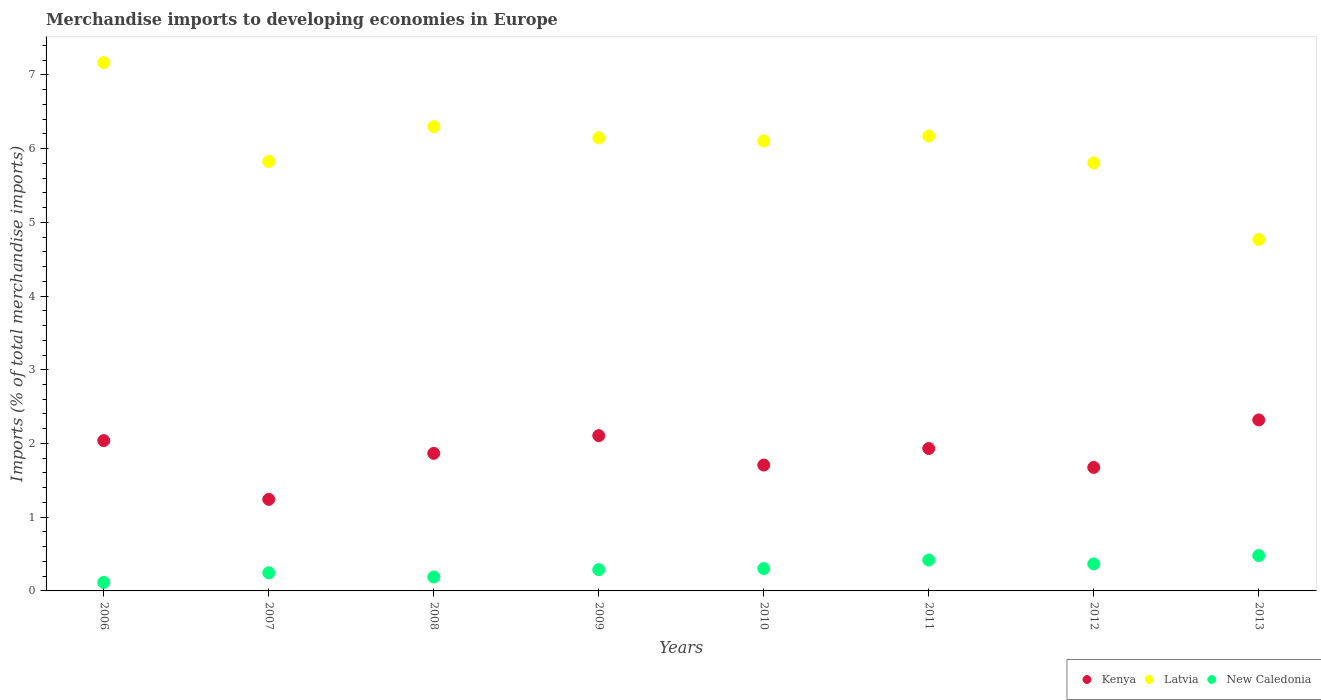What is the percentage total merchandise imports in New Caledonia in 2010?
Provide a short and direct response. 0.3. Across all years, what is the maximum percentage total merchandise imports in Latvia?
Give a very brief answer. 7.17. Across all years, what is the minimum percentage total merchandise imports in New Caledonia?
Your answer should be compact. 0.12. In which year was the percentage total merchandise imports in Kenya maximum?
Provide a succinct answer. 2013. In which year was the percentage total merchandise imports in Kenya minimum?
Provide a succinct answer. 2007. What is the total percentage total merchandise imports in Latvia in the graph?
Provide a succinct answer. 48.28. What is the difference between the percentage total merchandise imports in New Caledonia in 2007 and that in 2012?
Your answer should be very brief. -0.12. What is the difference between the percentage total merchandise imports in Kenya in 2007 and the percentage total merchandise imports in Latvia in 2010?
Provide a short and direct response. -4.86. What is the average percentage total merchandise imports in Kenya per year?
Make the answer very short. 1.86. In the year 2013, what is the difference between the percentage total merchandise imports in Latvia and percentage total merchandise imports in New Caledonia?
Offer a terse response. 4.29. In how many years, is the percentage total merchandise imports in Kenya greater than 6.8 %?
Keep it short and to the point. 0. What is the ratio of the percentage total merchandise imports in New Caledonia in 2009 to that in 2010?
Your response must be concise. 0.95. What is the difference between the highest and the second highest percentage total merchandise imports in Kenya?
Your answer should be compact. 0.21. What is the difference between the highest and the lowest percentage total merchandise imports in Kenya?
Offer a very short reply. 1.08. In how many years, is the percentage total merchandise imports in Kenya greater than the average percentage total merchandise imports in Kenya taken over all years?
Your answer should be compact. 5. Is the sum of the percentage total merchandise imports in New Caledonia in 2009 and 2011 greater than the maximum percentage total merchandise imports in Latvia across all years?
Make the answer very short. No. Is it the case that in every year, the sum of the percentage total merchandise imports in New Caledonia and percentage total merchandise imports in Latvia  is greater than the percentage total merchandise imports in Kenya?
Your answer should be very brief. Yes. Does the percentage total merchandise imports in Kenya monotonically increase over the years?
Offer a terse response. No. Is the percentage total merchandise imports in New Caledonia strictly less than the percentage total merchandise imports in Kenya over the years?
Give a very brief answer. Yes. Does the graph contain any zero values?
Your answer should be very brief. No. Does the graph contain grids?
Provide a short and direct response. No. Where does the legend appear in the graph?
Offer a terse response. Bottom right. What is the title of the graph?
Keep it short and to the point. Merchandise imports to developing economies in Europe. Does "Mali" appear as one of the legend labels in the graph?
Your response must be concise. No. What is the label or title of the Y-axis?
Give a very brief answer. Imports (% of total merchandise imports). What is the Imports (% of total merchandise imports) in Kenya in 2006?
Ensure brevity in your answer.  2.04. What is the Imports (% of total merchandise imports) of Latvia in 2006?
Your answer should be compact. 7.17. What is the Imports (% of total merchandise imports) in New Caledonia in 2006?
Your answer should be compact. 0.12. What is the Imports (% of total merchandise imports) in Kenya in 2007?
Provide a short and direct response. 1.24. What is the Imports (% of total merchandise imports) of Latvia in 2007?
Provide a succinct answer. 5.83. What is the Imports (% of total merchandise imports) of New Caledonia in 2007?
Your response must be concise. 0.25. What is the Imports (% of total merchandise imports) of Kenya in 2008?
Ensure brevity in your answer.  1.87. What is the Imports (% of total merchandise imports) in Latvia in 2008?
Provide a short and direct response. 6.3. What is the Imports (% of total merchandise imports) in New Caledonia in 2008?
Provide a short and direct response. 0.19. What is the Imports (% of total merchandise imports) in Kenya in 2009?
Keep it short and to the point. 2.11. What is the Imports (% of total merchandise imports) of Latvia in 2009?
Make the answer very short. 6.15. What is the Imports (% of total merchandise imports) of New Caledonia in 2009?
Keep it short and to the point. 0.29. What is the Imports (% of total merchandise imports) of Kenya in 2010?
Offer a terse response. 1.71. What is the Imports (% of total merchandise imports) of Latvia in 2010?
Provide a short and direct response. 6.1. What is the Imports (% of total merchandise imports) in New Caledonia in 2010?
Give a very brief answer. 0.3. What is the Imports (% of total merchandise imports) in Kenya in 2011?
Offer a very short reply. 1.93. What is the Imports (% of total merchandise imports) in Latvia in 2011?
Keep it short and to the point. 6.17. What is the Imports (% of total merchandise imports) of New Caledonia in 2011?
Provide a succinct answer. 0.42. What is the Imports (% of total merchandise imports) in Kenya in 2012?
Provide a short and direct response. 1.68. What is the Imports (% of total merchandise imports) in Latvia in 2012?
Your answer should be very brief. 5.81. What is the Imports (% of total merchandise imports) in New Caledonia in 2012?
Ensure brevity in your answer.  0.37. What is the Imports (% of total merchandise imports) in Kenya in 2013?
Keep it short and to the point. 2.32. What is the Imports (% of total merchandise imports) of Latvia in 2013?
Keep it short and to the point. 4.77. What is the Imports (% of total merchandise imports) of New Caledonia in 2013?
Ensure brevity in your answer.  0.48. Across all years, what is the maximum Imports (% of total merchandise imports) of Kenya?
Provide a succinct answer. 2.32. Across all years, what is the maximum Imports (% of total merchandise imports) of Latvia?
Offer a very short reply. 7.17. Across all years, what is the maximum Imports (% of total merchandise imports) of New Caledonia?
Give a very brief answer. 0.48. Across all years, what is the minimum Imports (% of total merchandise imports) in Kenya?
Make the answer very short. 1.24. Across all years, what is the minimum Imports (% of total merchandise imports) of Latvia?
Provide a short and direct response. 4.77. Across all years, what is the minimum Imports (% of total merchandise imports) of New Caledonia?
Keep it short and to the point. 0.12. What is the total Imports (% of total merchandise imports) in Kenya in the graph?
Give a very brief answer. 14.89. What is the total Imports (% of total merchandise imports) in Latvia in the graph?
Your answer should be compact. 48.28. What is the total Imports (% of total merchandise imports) in New Caledonia in the graph?
Ensure brevity in your answer.  2.41. What is the difference between the Imports (% of total merchandise imports) of Kenya in 2006 and that in 2007?
Offer a very short reply. 0.8. What is the difference between the Imports (% of total merchandise imports) of Latvia in 2006 and that in 2007?
Offer a terse response. 1.34. What is the difference between the Imports (% of total merchandise imports) in New Caledonia in 2006 and that in 2007?
Your answer should be compact. -0.13. What is the difference between the Imports (% of total merchandise imports) in Kenya in 2006 and that in 2008?
Offer a very short reply. 0.17. What is the difference between the Imports (% of total merchandise imports) of Latvia in 2006 and that in 2008?
Your response must be concise. 0.87. What is the difference between the Imports (% of total merchandise imports) in New Caledonia in 2006 and that in 2008?
Give a very brief answer. -0.07. What is the difference between the Imports (% of total merchandise imports) of Kenya in 2006 and that in 2009?
Your answer should be compact. -0.07. What is the difference between the Imports (% of total merchandise imports) in Latvia in 2006 and that in 2009?
Keep it short and to the point. 1.02. What is the difference between the Imports (% of total merchandise imports) in New Caledonia in 2006 and that in 2009?
Give a very brief answer. -0.17. What is the difference between the Imports (% of total merchandise imports) of Kenya in 2006 and that in 2010?
Offer a terse response. 0.33. What is the difference between the Imports (% of total merchandise imports) of Latvia in 2006 and that in 2010?
Make the answer very short. 1.06. What is the difference between the Imports (% of total merchandise imports) in New Caledonia in 2006 and that in 2010?
Offer a terse response. -0.19. What is the difference between the Imports (% of total merchandise imports) in Kenya in 2006 and that in 2011?
Offer a terse response. 0.11. What is the difference between the Imports (% of total merchandise imports) of Latvia in 2006 and that in 2011?
Your response must be concise. 1. What is the difference between the Imports (% of total merchandise imports) in New Caledonia in 2006 and that in 2011?
Keep it short and to the point. -0.3. What is the difference between the Imports (% of total merchandise imports) of Kenya in 2006 and that in 2012?
Give a very brief answer. 0.36. What is the difference between the Imports (% of total merchandise imports) in Latvia in 2006 and that in 2012?
Your answer should be compact. 1.36. What is the difference between the Imports (% of total merchandise imports) of New Caledonia in 2006 and that in 2012?
Keep it short and to the point. -0.25. What is the difference between the Imports (% of total merchandise imports) in Kenya in 2006 and that in 2013?
Make the answer very short. -0.28. What is the difference between the Imports (% of total merchandise imports) of Latvia in 2006 and that in 2013?
Give a very brief answer. 2.4. What is the difference between the Imports (% of total merchandise imports) of New Caledonia in 2006 and that in 2013?
Ensure brevity in your answer.  -0.36. What is the difference between the Imports (% of total merchandise imports) of Kenya in 2007 and that in 2008?
Provide a succinct answer. -0.62. What is the difference between the Imports (% of total merchandise imports) of Latvia in 2007 and that in 2008?
Ensure brevity in your answer.  -0.47. What is the difference between the Imports (% of total merchandise imports) in New Caledonia in 2007 and that in 2008?
Your answer should be very brief. 0.06. What is the difference between the Imports (% of total merchandise imports) in Kenya in 2007 and that in 2009?
Provide a short and direct response. -0.86. What is the difference between the Imports (% of total merchandise imports) of Latvia in 2007 and that in 2009?
Keep it short and to the point. -0.32. What is the difference between the Imports (% of total merchandise imports) in New Caledonia in 2007 and that in 2009?
Offer a terse response. -0.04. What is the difference between the Imports (% of total merchandise imports) of Kenya in 2007 and that in 2010?
Your answer should be very brief. -0.47. What is the difference between the Imports (% of total merchandise imports) in Latvia in 2007 and that in 2010?
Offer a very short reply. -0.28. What is the difference between the Imports (% of total merchandise imports) of New Caledonia in 2007 and that in 2010?
Offer a very short reply. -0.06. What is the difference between the Imports (% of total merchandise imports) in Kenya in 2007 and that in 2011?
Provide a succinct answer. -0.69. What is the difference between the Imports (% of total merchandise imports) in Latvia in 2007 and that in 2011?
Make the answer very short. -0.34. What is the difference between the Imports (% of total merchandise imports) of New Caledonia in 2007 and that in 2011?
Offer a terse response. -0.17. What is the difference between the Imports (% of total merchandise imports) in Kenya in 2007 and that in 2012?
Provide a succinct answer. -0.43. What is the difference between the Imports (% of total merchandise imports) of Latvia in 2007 and that in 2012?
Your response must be concise. 0.02. What is the difference between the Imports (% of total merchandise imports) of New Caledonia in 2007 and that in 2012?
Provide a succinct answer. -0.12. What is the difference between the Imports (% of total merchandise imports) of Kenya in 2007 and that in 2013?
Your answer should be compact. -1.08. What is the difference between the Imports (% of total merchandise imports) of Latvia in 2007 and that in 2013?
Keep it short and to the point. 1.06. What is the difference between the Imports (% of total merchandise imports) in New Caledonia in 2007 and that in 2013?
Keep it short and to the point. -0.23. What is the difference between the Imports (% of total merchandise imports) in Kenya in 2008 and that in 2009?
Make the answer very short. -0.24. What is the difference between the Imports (% of total merchandise imports) of Latvia in 2008 and that in 2009?
Your answer should be compact. 0.15. What is the difference between the Imports (% of total merchandise imports) of New Caledonia in 2008 and that in 2009?
Your answer should be compact. -0.1. What is the difference between the Imports (% of total merchandise imports) of Kenya in 2008 and that in 2010?
Ensure brevity in your answer.  0.16. What is the difference between the Imports (% of total merchandise imports) in Latvia in 2008 and that in 2010?
Make the answer very short. 0.19. What is the difference between the Imports (% of total merchandise imports) in New Caledonia in 2008 and that in 2010?
Provide a succinct answer. -0.11. What is the difference between the Imports (% of total merchandise imports) of Kenya in 2008 and that in 2011?
Keep it short and to the point. -0.07. What is the difference between the Imports (% of total merchandise imports) in Latvia in 2008 and that in 2011?
Your response must be concise. 0.13. What is the difference between the Imports (% of total merchandise imports) of New Caledonia in 2008 and that in 2011?
Provide a succinct answer. -0.23. What is the difference between the Imports (% of total merchandise imports) in Kenya in 2008 and that in 2012?
Give a very brief answer. 0.19. What is the difference between the Imports (% of total merchandise imports) of Latvia in 2008 and that in 2012?
Your answer should be compact. 0.49. What is the difference between the Imports (% of total merchandise imports) in New Caledonia in 2008 and that in 2012?
Offer a terse response. -0.18. What is the difference between the Imports (% of total merchandise imports) in Kenya in 2008 and that in 2013?
Your answer should be compact. -0.45. What is the difference between the Imports (% of total merchandise imports) of Latvia in 2008 and that in 2013?
Keep it short and to the point. 1.53. What is the difference between the Imports (% of total merchandise imports) of New Caledonia in 2008 and that in 2013?
Provide a succinct answer. -0.29. What is the difference between the Imports (% of total merchandise imports) of Kenya in 2009 and that in 2010?
Offer a terse response. 0.4. What is the difference between the Imports (% of total merchandise imports) of Latvia in 2009 and that in 2010?
Provide a succinct answer. 0.04. What is the difference between the Imports (% of total merchandise imports) in New Caledonia in 2009 and that in 2010?
Your answer should be very brief. -0.01. What is the difference between the Imports (% of total merchandise imports) in Kenya in 2009 and that in 2011?
Make the answer very short. 0.17. What is the difference between the Imports (% of total merchandise imports) in Latvia in 2009 and that in 2011?
Provide a succinct answer. -0.02. What is the difference between the Imports (% of total merchandise imports) in New Caledonia in 2009 and that in 2011?
Offer a very short reply. -0.13. What is the difference between the Imports (% of total merchandise imports) of Kenya in 2009 and that in 2012?
Keep it short and to the point. 0.43. What is the difference between the Imports (% of total merchandise imports) in Latvia in 2009 and that in 2012?
Your answer should be compact. 0.34. What is the difference between the Imports (% of total merchandise imports) in New Caledonia in 2009 and that in 2012?
Provide a short and direct response. -0.08. What is the difference between the Imports (% of total merchandise imports) in Kenya in 2009 and that in 2013?
Keep it short and to the point. -0.21. What is the difference between the Imports (% of total merchandise imports) of Latvia in 2009 and that in 2013?
Give a very brief answer. 1.38. What is the difference between the Imports (% of total merchandise imports) in New Caledonia in 2009 and that in 2013?
Offer a very short reply. -0.19. What is the difference between the Imports (% of total merchandise imports) in Kenya in 2010 and that in 2011?
Provide a succinct answer. -0.22. What is the difference between the Imports (% of total merchandise imports) of Latvia in 2010 and that in 2011?
Offer a very short reply. -0.07. What is the difference between the Imports (% of total merchandise imports) of New Caledonia in 2010 and that in 2011?
Offer a very short reply. -0.12. What is the difference between the Imports (% of total merchandise imports) in Kenya in 2010 and that in 2012?
Your answer should be compact. 0.03. What is the difference between the Imports (% of total merchandise imports) in Latvia in 2010 and that in 2012?
Provide a short and direct response. 0.3. What is the difference between the Imports (% of total merchandise imports) of New Caledonia in 2010 and that in 2012?
Your answer should be compact. -0.06. What is the difference between the Imports (% of total merchandise imports) of Kenya in 2010 and that in 2013?
Your response must be concise. -0.61. What is the difference between the Imports (% of total merchandise imports) in Latvia in 2010 and that in 2013?
Keep it short and to the point. 1.34. What is the difference between the Imports (% of total merchandise imports) of New Caledonia in 2010 and that in 2013?
Offer a terse response. -0.18. What is the difference between the Imports (% of total merchandise imports) of Kenya in 2011 and that in 2012?
Provide a short and direct response. 0.26. What is the difference between the Imports (% of total merchandise imports) in Latvia in 2011 and that in 2012?
Your answer should be very brief. 0.36. What is the difference between the Imports (% of total merchandise imports) in New Caledonia in 2011 and that in 2012?
Ensure brevity in your answer.  0.05. What is the difference between the Imports (% of total merchandise imports) in Kenya in 2011 and that in 2013?
Your answer should be compact. -0.39. What is the difference between the Imports (% of total merchandise imports) of Latvia in 2011 and that in 2013?
Ensure brevity in your answer.  1.4. What is the difference between the Imports (% of total merchandise imports) of New Caledonia in 2011 and that in 2013?
Offer a very short reply. -0.06. What is the difference between the Imports (% of total merchandise imports) in Kenya in 2012 and that in 2013?
Keep it short and to the point. -0.64. What is the difference between the Imports (% of total merchandise imports) of Latvia in 2012 and that in 2013?
Make the answer very short. 1.04. What is the difference between the Imports (% of total merchandise imports) of New Caledonia in 2012 and that in 2013?
Your response must be concise. -0.11. What is the difference between the Imports (% of total merchandise imports) in Kenya in 2006 and the Imports (% of total merchandise imports) in Latvia in 2007?
Your answer should be very brief. -3.79. What is the difference between the Imports (% of total merchandise imports) of Kenya in 2006 and the Imports (% of total merchandise imports) of New Caledonia in 2007?
Give a very brief answer. 1.79. What is the difference between the Imports (% of total merchandise imports) in Latvia in 2006 and the Imports (% of total merchandise imports) in New Caledonia in 2007?
Your answer should be very brief. 6.92. What is the difference between the Imports (% of total merchandise imports) of Kenya in 2006 and the Imports (% of total merchandise imports) of Latvia in 2008?
Your response must be concise. -4.26. What is the difference between the Imports (% of total merchandise imports) of Kenya in 2006 and the Imports (% of total merchandise imports) of New Caledonia in 2008?
Provide a succinct answer. 1.85. What is the difference between the Imports (% of total merchandise imports) in Latvia in 2006 and the Imports (% of total merchandise imports) in New Caledonia in 2008?
Keep it short and to the point. 6.98. What is the difference between the Imports (% of total merchandise imports) in Kenya in 2006 and the Imports (% of total merchandise imports) in Latvia in 2009?
Offer a terse response. -4.11. What is the difference between the Imports (% of total merchandise imports) of Kenya in 2006 and the Imports (% of total merchandise imports) of New Caledonia in 2009?
Give a very brief answer. 1.75. What is the difference between the Imports (% of total merchandise imports) of Latvia in 2006 and the Imports (% of total merchandise imports) of New Caledonia in 2009?
Give a very brief answer. 6.88. What is the difference between the Imports (% of total merchandise imports) of Kenya in 2006 and the Imports (% of total merchandise imports) of Latvia in 2010?
Your response must be concise. -4.06. What is the difference between the Imports (% of total merchandise imports) in Kenya in 2006 and the Imports (% of total merchandise imports) in New Caledonia in 2010?
Offer a very short reply. 1.74. What is the difference between the Imports (% of total merchandise imports) of Latvia in 2006 and the Imports (% of total merchandise imports) of New Caledonia in 2010?
Give a very brief answer. 6.86. What is the difference between the Imports (% of total merchandise imports) of Kenya in 2006 and the Imports (% of total merchandise imports) of Latvia in 2011?
Your response must be concise. -4.13. What is the difference between the Imports (% of total merchandise imports) in Kenya in 2006 and the Imports (% of total merchandise imports) in New Caledonia in 2011?
Make the answer very short. 1.62. What is the difference between the Imports (% of total merchandise imports) in Latvia in 2006 and the Imports (% of total merchandise imports) in New Caledonia in 2011?
Your answer should be compact. 6.75. What is the difference between the Imports (% of total merchandise imports) in Kenya in 2006 and the Imports (% of total merchandise imports) in Latvia in 2012?
Keep it short and to the point. -3.77. What is the difference between the Imports (% of total merchandise imports) of Kenya in 2006 and the Imports (% of total merchandise imports) of New Caledonia in 2012?
Make the answer very short. 1.67. What is the difference between the Imports (% of total merchandise imports) in Latvia in 2006 and the Imports (% of total merchandise imports) in New Caledonia in 2012?
Keep it short and to the point. 6.8. What is the difference between the Imports (% of total merchandise imports) in Kenya in 2006 and the Imports (% of total merchandise imports) in Latvia in 2013?
Your answer should be very brief. -2.73. What is the difference between the Imports (% of total merchandise imports) in Kenya in 2006 and the Imports (% of total merchandise imports) in New Caledonia in 2013?
Offer a very short reply. 1.56. What is the difference between the Imports (% of total merchandise imports) in Latvia in 2006 and the Imports (% of total merchandise imports) in New Caledonia in 2013?
Offer a very short reply. 6.69. What is the difference between the Imports (% of total merchandise imports) in Kenya in 2007 and the Imports (% of total merchandise imports) in Latvia in 2008?
Offer a terse response. -5.06. What is the difference between the Imports (% of total merchandise imports) in Kenya in 2007 and the Imports (% of total merchandise imports) in New Caledonia in 2008?
Provide a short and direct response. 1.05. What is the difference between the Imports (% of total merchandise imports) in Latvia in 2007 and the Imports (% of total merchandise imports) in New Caledonia in 2008?
Keep it short and to the point. 5.64. What is the difference between the Imports (% of total merchandise imports) of Kenya in 2007 and the Imports (% of total merchandise imports) of Latvia in 2009?
Keep it short and to the point. -4.9. What is the difference between the Imports (% of total merchandise imports) in Kenya in 2007 and the Imports (% of total merchandise imports) in New Caledonia in 2009?
Keep it short and to the point. 0.95. What is the difference between the Imports (% of total merchandise imports) in Latvia in 2007 and the Imports (% of total merchandise imports) in New Caledonia in 2009?
Offer a very short reply. 5.54. What is the difference between the Imports (% of total merchandise imports) in Kenya in 2007 and the Imports (% of total merchandise imports) in Latvia in 2010?
Offer a terse response. -4.86. What is the difference between the Imports (% of total merchandise imports) of Kenya in 2007 and the Imports (% of total merchandise imports) of New Caledonia in 2010?
Provide a succinct answer. 0.94. What is the difference between the Imports (% of total merchandise imports) in Latvia in 2007 and the Imports (% of total merchandise imports) in New Caledonia in 2010?
Keep it short and to the point. 5.52. What is the difference between the Imports (% of total merchandise imports) in Kenya in 2007 and the Imports (% of total merchandise imports) in Latvia in 2011?
Offer a terse response. -4.93. What is the difference between the Imports (% of total merchandise imports) of Kenya in 2007 and the Imports (% of total merchandise imports) of New Caledonia in 2011?
Your response must be concise. 0.82. What is the difference between the Imports (% of total merchandise imports) of Latvia in 2007 and the Imports (% of total merchandise imports) of New Caledonia in 2011?
Make the answer very short. 5.41. What is the difference between the Imports (% of total merchandise imports) of Kenya in 2007 and the Imports (% of total merchandise imports) of Latvia in 2012?
Make the answer very short. -4.56. What is the difference between the Imports (% of total merchandise imports) in Kenya in 2007 and the Imports (% of total merchandise imports) in New Caledonia in 2012?
Your answer should be very brief. 0.88. What is the difference between the Imports (% of total merchandise imports) of Latvia in 2007 and the Imports (% of total merchandise imports) of New Caledonia in 2012?
Offer a terse response. 5.46. What is the difference between the Imports (% of total merchandise imports) in Kenya in 2007 and the Imports (% of total merchandise imports) in Latvia in 2013?
Give a very brief answer. -3.52. What is the difference between the Imports (% of total merchandise imports) of Kenya in 2007 and the Imports (% of total merchandise imports) of New Caledonia in 2013?
Provide a short and direct response. 0.76. What is the difference between the Imports (% of total merchandise imports) of Latvia in 2007 and the Imports (% of total merchandise imports) of New Caledonia in 2013?
Offer a very short reply. 5.35. What is the difference between the Imports (% of total merchandise imports) in Kenya in 2008 and the Imports (% of total merchandise imports) in Latvia in 2009?
Provide a short and direct response. -4.28. What is the difference between the Imports (% of total merchandise imports) in Kenya in 2008 and the Imports (% of total merchandise imports) in New Caledonia in 2009?
Provide a short and direct response. 1.58. What is the difference between the Imports (% of total merchandise imports) of Latvia in 2008 and the Imports (% of total merchandise imports) of New Caledonia in 2009?
Provide a succinct answer. 6.01. What is the difference between the Imports (% of total merchandise imports) of Kenya in 2008 and the Imports (% of total merchandise imports) of Latvia in 2010?
Keep it short and to the point. -4.24. What is the difference between the Imports (% of total merchandise imports) of Kenya in 2008 and the Imports (% of total merchandise imports) of New Caledonia in 2010?
Provide a succinct answer. 1.56. What is the difference between the Imports (% of total merchandise imports) in Latvia in 2008 and the Imports (% of total merchandise imports) in New Caledonia in 2010?
Your answer should be very brief. 6. What is the difference between the Imports (% of total merchandise imports) in Kenya in 2008 and the Imports (% of total merchandise imports) in Latvia in 2011?
Your answer should be very brief. -4.3. What is the difference between the Imports (% of total merchandise imports) of Kenya in 2008 and the Imports (% of total merchandise imports) of New Caledonia in 2011?
Offer a terse response. 1.45. What is the difference between the Imports (% of total merchandise imports) in Latvia in 2008 and the Imports (% of total merchandise imports) in New Caledonia in 2011?
Offer a very short reply. 5.88. What is the difference between the Imports (% of total merchandise imports) in Kenya in 2008 and the Imports (% of total merchandise imports) in Latvia in 2012?
Your response must be concise. -3.94. What is the difference between the Imports (% of total merchandise imports) of Kenya in 2008 and the Imports (% of total merchandise imports) of New Caledonia in 2012?
Your answer should be compact. 1.5. What is the difference between the Imports (% of total merchandise imports) of Latvia in 2008 and the Imports (% of total merchandise imports) of New Caledonia in 2012?
Give a very brief answer. 5.93. What is the difference between the Imports (% of total merchandise imports) of Kenya in 2008 and the Imports (% of total merchandise imports) of Latvia in 2013?
Your response must be concise. -2.9. What is the difference between the Imports (% of total merchandise imports) in Kenya in 2008 and the Imports (% of total merchandise imports) in New Caledonia in 2013?
Give a very brief answer. 1.39. What is the difference between the Imports (% of total merchandise imports) of Latvia in 2008 and the Imports (% of total merchandise imports) of New Caledonia in 2013?
Ensure brevity in your answer.  5.82. What is the difference between the Imports (% of total merchandise imports) in Kenya in 2009 and the Imports (% of total merchandise imports) in Latvia in 2010?
Your answer should be very brief. -4. What is the difference between the Imports (% of total merchandise imports) in Kenya in 2009 and the Imports (% of total merchandise imports) in New Caledonia in 2010?
Provide a short and direct response. 1.8. What is the difference between the Imports (% of total merchandise imports) of Latvia in 2009 and the Imports (% of total merchandise imports) of New Caledonia in 2010?
Provide a succinct answer. 5.84. What is the difference between the Imports (% of total merchandise imports) in Kenya in 2009 and the Imports (% of total merchandise imports) in Latvia in 2011?
Provide a short and direct response. -4.06. What is the difference between the Imports (% of total merchandise imports) in Kenya in 2009 and the Imports (% of total merchandise imports) in New Caledonia in 2011?
Provide a succinct answer. 1.69. What is the difference between the Imports (% of total merchandise imports) in Latvia in 2009 and the Imports (% of total merchandise imports) in New Caledonia in 2011?
Make the answer very short. 5.73. What is the difference between the Imports (% of total merchandise imports) of Kenya in 2009 and the Imports (% of total merchandise imports) of Latvia in 2012?
Keep it short and to the point. -3.7. What is the difference between the Imports (% of total merchandise imports) of Kenya in 2009 and the Imports (% of total merchandise imports) of New Caledonia in 2012?
Your answer should be compact. 1.74. What is the difference between the Imports (% of total merchandise imports) of Latvia in 2009 and the Imports (% of total merchandise imports) of New Caledonia in 2012?
Offer a very short reply. 5.78. What is the difference between the Imports (% of total merchandise imports) of Kenya in 2009 and the Imports (% of total merchandise imports) of Latvia in 2013?
Provide a short and direct response. -2.66. What is the difference between the Imports (% of total merchandise imports) in Kenya in 2009 and the Imports (% of total merchandise imports) in New Caledonia in 2013?
Provide a succinct answer. 1.63. What is the difference between the Imports (% of total merchandise imports) in Latvia in 2009 and the Imports (% of total merchandise imports) in New Caledonia in 2013?
Give a very brief answer. 5.67. What is the difference between the Imports (% of total merchandise imports) in Kenya in 2010 and the Imports (% of total merchandise imports) in Latvia in 2011?
Your answer should be compact. -4.46. What is the difference between the Imports (% of total merchandise imports) in Kenya in 2010 and the Imports (% of total merchandise imports) in New Caledonia in 2011?
Make the answer very short. 1.29. What is the difference between the Imports (% of total merchandise imports) in Latvia in 2010 and the Imports (% of total merchandise imports) in New Caledonia in 2011?
Your response must be concise. 5.68. What is the difference between the Imports (% of total merchandise imports) in Kenya in 2010 and the Imports (% of total merchandise imports) in Latvia in 2012?
Ensure brevity in your answer.  -4.1. What is the difference between the Imports (% of total merchandise imports) in Kenya in 2010 and the Imports (% of total merchandise imports) in New Caledonia in 2012?
Ensure brevity in your answer.  1.34. What is the difference between the Imports (% of total merchandise imports) in Latvia in 2010 and the Imports (% of total merchandise imports) in New Caledonia in 2012?
Provide a short and direct response. 5.74. What is the difference between the Imports (% of total merchandise imports) in Kenya in 2010 and the Imports (% of total merchandise imports) in Latvia in 2013?
Keep it short and to the point. -3.06. What is the difference between the Imports (% of total merchandise imports) in Kenya in 2010 and the Imports (% of total merchandise imports) in New Caledonia in 2013?
Your response must be concise. 1.23. What is the difference between the Imports (% of total merchandise imports) in Latvia in 2010 and the Imports (% of total merchandise imports) in New Caledonia in 2013?
Provide a succinct answer. 5.62. What is the difference between the Imports (% of total merchandise imports) of Kenya in 2011 and the Imports (% of total merchandise imports) of Latvia in 2012?
Provide a succinct answer. -3.87. What is the difference between the Imports (% of total merchandise imports) of Kenya in 2011 and the Imports (% of total merchandise imports) of New Caledonia in 2012?
Offer a terse response. 1.57. What is the difference between the Imports (% of total merchandise imports) of Latvia in 2011 and the Imports (% of total merchandise imports) of New Caledonia in 2012?
Offer a very short reply. 5.8. What is the difference between the Imports (% of total merchandise imports) in Kenya in 2011 and the Imports (% of total merchandise imports) in Latvia in 2013?
Provide a succinct answer. -2.83. What is the difference between the Imports (% of total merchandise imports) in Kenya in 2011 and the Imports (% of total merchandise imports) in New Caledonia in 2013?
Ensure brevity in your answer.  1.45. What is the difference between the Imports (% of total merchandise imports) of Latvia in 2011 and the Imports (% of total merchandise imports) of New Caledonia in 2013?
Your answer should be compact. 5.69. What is the difference between the Imports (% of total merchandise imports) of Kenya in 2012 and the Imports (% of total merchandise imports) of Latvia in 2013?
Keep it short and to the point. -3.09. What is the difference between the Imports (% of total merchandise imports) in Kenya in 2012 and the Imports (% of total merchandise imports) in New Caledonia in 2013?
Keep it short and to the point. 1.2. What is the difference between the Imports (% of total merchandise imports) of Latvia in 2012 and the Imports (% of total merchandise imports) of New Caledonia in 2013?
Offer a terse response. 5.33. What is the average Imports (% of total merchandise imports) in Kenya per year?
Provide a succinct answer. 1.86. What is the average Imports (% of total merchandise imports) in Latvia per year?
Provide a short and direct response. 6.04. What is the average Imports (% of total merchandise imports) in New Caledonia per year?
Your answer should be compact. 0.3. In the year 2006, what is the difference between the Imports (% of total merchandise imports) in Kenya and Imports (% of total merchandise imports) in Latvia?
Make the answer very short. -5.13. In the year 2006, what is the difference between the Imports (% of total merchandise imports) in Kenya and Imports (% of total merchandise imports) in New Caledonia?
Keep it short and to the point. 1.92. In the year 2006, what is the difference between the Imports (% of total merchandise imports) in Latvia and Imports (% of total merchandise imports) in New Caledonia?
Offer a very short reply. 7.05. In the year 2007, what is the difference between the Imports (% of total merchandise imports) of Kenya and Imports (% of total merchandise imports) of Latvia?
Ensure brevity in your answer.  -4.58. In the year 2007, what is the difference between the Imports (% of total merchandise imports) of Kenya and Imports (% of total merchandise imports) of New Caledonia?
Give a very brief answer. 1. In the year 2007, what is the difference between the Imports (% of total merchandise imports) of Latvia and Imports (% of total merchandise imports) of New Caledonia?
Ensure brevity in your answer.  5.58. In the year 2008, what is the difference between the Imports (% of total merchandise imports) in Kenya and Imports (% of total merchandise imports) in Latvia?
Offer a very short reply. -4.43. In the year 2008, what is the difference between the Imports (% of total merchandise imports) of Kenya and Imports (% of total merchandise imports) of New Caledonia?
Your response must be concise. 1.68. In the year 2008, what is the difference between the Imports (% of total merchandise imports) of Latvia and Imports (% of total merchandise imports) of New Caledonia?
Keep it short and to the point. 6.11. In the year 2009, what is the difference between the Imports (% of total merchandise imports) of Kenya and Imports (% of total merchandise imports) of Latvia?
Provide a short and direct response. -4.04. In the year 2009, what is the difference between the Imports (% of total merchandise imports) of Kenya and Imports (% of total merchandise imports) of New Caledonia?
Your answer should be compact. 1.82. In the year 2009, what is the difference between the Imports (% of total merchandise imports) of Latvia and Imports (% of total merchandise imports) of New Caledonia?
Provide a short and direct response. 5.86. In the year 2010, what is the difference between the Imports (% of total merchandise imports) in Kenya and Imports (% of total merchandise imports) in Latvia?
Provide a succinct answer. -4.4. In the year 2010, what is the difference between the Imports (% of total merchandise imports) in Kenya and Imports (% of total merchandise imports) in New Caledonia?
Offer a terse response. 1.4. In the year 2010, what is the difference between the Imports (% of total merchandise imports) of Latvia and Imports (% of total merchandise imports) of New Caledonia?
Offer a very short reply. 5.8. In the year 2011, what is the difference between the Imports (% of total merchandise imports) of Kenya and Imports (% of total merchandise imports) of Latvia?
Your answer should be compact. -4.24. In the year 2011, what is the difference between the Imports (% of total merchandise imports) in Kenya and Imports (% of total merchandise imports) in New Caledonia?
Offer a very short reply. 1.51. In the year 2011, what is the difference between the Imports (% of total merchandise imports) of Latvia and Imports (% of total merchandise imports) of New Caledonia?
Offer a terse response. 5.75. In the year 2012, what is the difference between the Imports (% of total merchandise imports) in Kenya and Imports (% of total merchandise imports) in Latvia?
Make the answer very short. -4.13. In the year 2012, what is the difference between the Imports (% of total merchandise imports) in Kenya and Imports (% of total merchandise imports) in New Caledonia?
Keep it short and to the point. 1.31. In the year 2012, what is the difference between the Imports (% of total merchandise imports) in Latvia and Imports (% of total merchandise imports) in New Caledonia?
Your answer should be very brief. 5.44. In the year 2013, what is the difference between the Imports (% of total merchandise imports) of Kenya and Imports (% of total merchandise imports) of Latvia?
Ensure brevity in your answer.  -2.45. In the year 2013, what is the difference between the Imports (% of total merchandise imports) of Kenya and Imports (% of total merchandise imports) of New Caledonia?
Your answer should be very brief. 1.84. In the year 2013, what is the difference between the Imports (% of total merchandise imports) of Latvia and Imports (% of total merchandise imports) of New Caledonia?
Offer a terse response. 4.29. What is the ratio of the Imports (% of total merchandise imports) of Kenya in 2006 to that in 2007?
Offer a very short reply. 1.64. What is the ratio of the Imports (% of total merchandise imports) of Latvia in 2006 to that in 2007?
Make the answer very short. 1.23. What is the ratio of the Imports (% of total merchandise imports) of New Caledonia in 2006 to that in 2007?
Your answer should be very brief. 0.47. What is the ratio of the Imports (% of total merchandise imports) of Kenya in 2006 to that in 2008?
Offer a terse response. 1.09. What is the ratio of the Imports (% of total merchandise imports) in Latvia in 2006 to that in 2008?
Keep it short and to the point. 1.14. What is the ratio of the Imports (% of total merchandise imports) in New Caledonia in 2006 to that in 2008?
Offer a very short reply. 0.61. What is the ratio of the Imports (% of total merchandise imports) in Kenya in 2006 to that in 2009?
Make the answer very short. 0.97. What is the ratio of the Imports (% of total merchandise imports) in Latvia in 2006 to that in 2009?
Keep it short and to the point. 1.17. What is the ratio of the Imports (% of total merchandise imports) in New Caledonia in 2006 to that in 2009?
Give a very brief answer. 0.4. What is the ratio of the Imports (% of total merchandise imports) of Kenya in 2006 to that in 2010?
Your response must be concise. 1.19. What is the ratio of the Imports (% of total merchandise imports) in Latvia in 2006 to that in 2010?
Make the answer very short. 1.17. What is the ratio of the Imports (% of total merchandise imports) of New Caledonia in 2006 to that in 2010?
Ensure brevity in your answer.  0.38. What is the ratio of the Imports (% of total merchandise imports) of Kenya in 2006 to that in 2011?
Your response must be concise. 1.06. What is the ratio of the Imports (% of total merchandise imports) in Latvia in 2006 to that in 2011?
Your answer should be very brief. 1.16. What is the ratio of the Imports (% of total merchandise imports) of New Caledonia in 2006 to that in 2011?
Keep it short and to the point. 0.28. What is the ratio of the Imports (% of total merchandise imports) of Kenya in 2006 to that in 2012?
Your answer should be compact. 1.22. What is the ratio of the Imports (% of total merchandise imports) of Latvia in 2006 to that in 2012?
Provide a short and direct response. 1.23. What is the ratio of the Imports (% of total merchandise imports) of New Caledonia in 2006 to that in 2012?
Keep it short and to the point. 0.32. What is the ratio of the Imports (% of total merchandise imports) of Kenya in 2006 to that in 2013?
Your answer should be compact. 0.88. What is the ratio of the Imports (% of total merchandise imports) in Latvia in 2006 to that in 2013?
Keep it short and to the point. 1.5. What is the ratio of the Imports (% of total merchandise imports) of New Caledonia in 2006 to that in 2013?
Offer a terse response. 0.24. What is the ratio of the Imports (% of total merchandise imports) in Kenya in 2007 to that in 2008?
Your answer should be very brief. 0.67. What is the ratio of the Imports (% of total merchandise imports) in Latvia in 2007 to that in 2008?
Provide a short and direct response. 0.93. What is the ratio of the Imports (% of total merchandise imports) of New Caledonia in 2007 to that in 2008?
Offer a very short reply. 1.3. What is the ratio of the Imports (% of total merchandise imports) of Kenya in 2007 to that in 2009?
Ensure brevity in your answer.  0.59. What is the ratio of the Imports (% of total merchandise imports) of Latvia in 2007 to that in 2009?
Keep it short and to the point. 0.95. What is the ratio of the Imports (% of total merchandise imports) in New Caledonia in 2007 to that in 2009?
Keep it short and to the point. 0.85. What is the ratio of the Imports (% of total merchandise imports) of Kenya in 2007 to that in 2010?
Give a very brief answer. 0.73. What is the ratio of the Imports (% of total merchandise imports) in Latvia in 2007 to that in 2010?
Your answer should be very brief. 0.95. What is the ratio of the Imports (% of total merchandise imports) in New Caledonia in 2007 to that in 2010?
Offer a terse response. 0.81. What is the ratio of the Imports (% of total merchandise imports) in Kenya in 2007 to that in 2011?
Keep it short and to the point. 0.64. What is the ratio of the Imports (% of total merchandise imports) in Latvia in 2007 to that in 2011?
Keep it short and to the point. 0.94. What is the ratio of the Imports (% of total merchandise imports) in New Caledonia in 2007 to that in 2011?
Make the answer very short. 0.59. What is the ratio of the Imports (% of total merchandise imports) of Kenya in 2007 to that in 2012?
Offer a very short reply. 0.74. What is the ratio of the Imports (% of total merchandise imports) in New Caledonia in 2007 to that in 2012?
Your response must be concise. 0.67. What is the ratio of the Imports (% of total merchandise imports) of Kenya in 2007 to that in 2013?
Your response must be concise. 0.54. What is the ratio of the Imports (% of total merchandise imports) of Latvia in 2007 to that in 2013?
Your answer should be compact. 1.22. What is the ratio of the Imports (% of total merchandise imports) of New Caledonia in 2007 to that in 2013?
Your answer should be very brief. 0.51. What is the ratio of the Imports (% of total merchandise imports) of Kenya in 2008 to that in 2009?
Provide a short and direct response. 0.89. What is the ratio of the Imports (% of total merchandise imports) of Latvia in 2008 to that in 2009?
Offer a terse response. 1.02. What is the ratio of the Imports (% of total merchandise imports) in New Caledonia in 2008 to that in 2009?
Make the answer very short. 0.65. What is the ratio of the Imports (% of total merchandise imports) in Kenya in 2008 to that in 2010?
Your response must be concise. 1.09. What is the ratio of the Imports (% of total merchandise imports) in Latvia in 2008 to that in 2010?
Offer a very short reply. 1.03. What is the ratio of the Imports (% of total merchandise imports) of New Caledonia in 2008 to that in 2010?
Make the answer very short. 0.62. What is the ratio of the Imports (% of total merchandise imports) of Kenya in 2008 to that in 2011?
Provide a succinct answer. 0.97. What is the ratio of the Imports (% of total merchandise imports) of Latvia in 2008 to that in 2011?
Ensure brevity in your answer.  1.02. What is the ratio of the Imports (% of total merchandise imports) in New Caledonia in 2008 to that in 2011?
Give a very brief answer. 0.45. What is the ratio of the Imports (% of total merchandise imports) of Kenya in 2008 to that in 2012?
Keep it short and to the point. 1.11. What is the ratio of the Imports (% of total merchandise imports) in Latvia in 2008 to that in 2012?
Your answer should be compact. 1.08. What is the ratio of the Imports (% of total merchandise imports) of New Caledonia in 2008 to that in 2012?
Offer a very short reply. 0.52. What is the ratio of the Imports (% of total merchandise imports) of Kenya in 2008 to that in 2013?
Offer a very short reply. 0.8. What is the ratio of the Imports (% of total merchandise imports) of Latvia in 2008 to that in 2013?
Give a very brief answer. 1.32. What is the ratio of the Imports (% of total merchandise imports) in New Caledonia in 2008 to that in 2013?
Keep it short and to the point. 0.39. What is the ratio of the Imports (% of total merchandise imports) in Kenya in 2009 to that in 2010?
Provide a succinct answer. 1.23. What is the ratio of the Imports (% of total merchandise imports) of New Caledonia in 2009 to that in 2010?
Make the answer very short. 0.95. What is the ratio of the Imports (% of total merchandise imports) in Kenya in 2009 to that in 2011?
Ensure brevity in your answer.  1.09. What is the ratio of the Imports (% of total merchandise imports) in New Caledonia in 2009 to that in 2011?
Your answer should be very brief. 0.69. What is the ratio of the Imports (% of total merchandise imports) in Kenya in 2009 to that in 2012?
Your response must be concise. 1.26. What is the ratio of the Imports (% of total merchandise imports) in Latvia in 2009 to that in 2012?
Provide a succinct answer. 1.06. What is the ratio of the Imports (% of total merchandise imports) of New Caledonia in 2009 to that in 2012?
Make the answer very short. 0.79. What is the ratio of the Imports (% of total merchandise imports) of Kenya in 2009 to that in 2013?
Give a very brief answer. 0.91. What is the ratio of the Imports (% of total merchandise imports) of Latvia in 2009 to that in 2013?
Ensure brevity in your answer.  1.29. What is the ratio of the Imports (% of total merchandise imports) in New Caledonia in 2009 to that in 2013?
Provide a short and direct response. 0.6. What is the ratio of the Imports (% of total merchandise imports) of Kenya in 2010 to that in 2011?
Provide a short and direct response. 0.88. What is the ratio of the Imports (% of total merchandise imports) in Latvia in 2010 to that in 2011?
Offer a very short reply. 0.99. What is the ratio of the Imports (% of total merchandise imports) in New Caledonia in 2010 to that in 2011?
Offer a very short reply. 0.72. What is the ratio of the Imports (% of total merchandise imports) of Kenya in 2010 to that in 2012?
Your response must be concise. 1.02. What is the ratio of the Imports (% of total merchandise imports) of Latvia in 2010 to that in 2012?
Your answer should be compact. 1.05. What is the ratio of the Imports (% of total merchandise imports) of New Caledonia in 2010 to that in 2012?
Offer a terse response. 0.83. What is the ratio of the Imports (% of total merchandise imports) in Kenya in 2010 to that in 2013?
Ensure brevity in your answer.  0.74. What is the ratio of the Imports (% of total merchandise imports) in Latvia in 2010 to that in 2013?
Your answer should be compact. 1.28. What is the ratio of the Imports (% of total merchandise imports) of New Caledonia in 2010 to that in 2013?
Ensure brevity in your answer.  0.63. What is the ratio of the Imports (% of total merchandise imports) of Kenya in 2011 to that in 2012?
Keep it short and to the point. 1.15. What is the ratio of the Imports (% of total merchandise imports) in Latvia in 2011 to that in 2012?
Offer a terse response. 1.06. What is the ratio of the Imports (% of total merchandise imports) of New Caledonia in 2011 to that in 2012?
Ensure brevity in your answer.  1.14. What is the ratio of the Imports (% of total merchandise imports) of Kenya in 2011 to that in 2013?
Offer a very short reply. 0.83. What is the ratio of the Imports (% of total merchandise imports) in Latvia in 2011 to that in 2013?
Offer a very short reply. 1.29. What is the ratio of the Imports (% of total merchandise imports) in New Caledonia in 2011 to that in 2013?
Your answer should be compact. 0.87. What is the ratio of the Imports (% of total merchandise imports) of Kenya in 2012 to that in 2013?
Ensure brevity in your answer.  0.72. What is the ratio of the Imports (% of total merchandise imports) in Latvia in 2012 to that in 2013?
Give a very brief answer. 1.22. What is the ratio of the Imports (% of total merchandise imports) in New Caledonia in 2012 to that in 2013?
Provide a short and direct response. 0.76. What is the difference between the highest and the second highest Imports (% of total merchandise imports) in Kenya?
Your answer should be compact. 0.21. What is the difference between the highest and the second highest Imports (% of total merchandise imports) in Latvia?
Ensure brevity in your answer.  0.87. What is the difference between the highest and the second highest Imports (% of total merchandise imports) in New Caledonia?
Ensure brevity in your answer.  0.06. What is the difference between the highest and the lowest Imports (% of total merchandise imports) in Kenya?
Your answer should be compact. 1.08. What is the difference between the highest and the lowest Imports (% of total merchandise imports) of Latvia?
Keep it short and to the point. 2.4. What is the difference between the highest and the lowest Imports (% of total merchandise imports) of New Caledonia?
Provide a succinct answer. 0.36. 